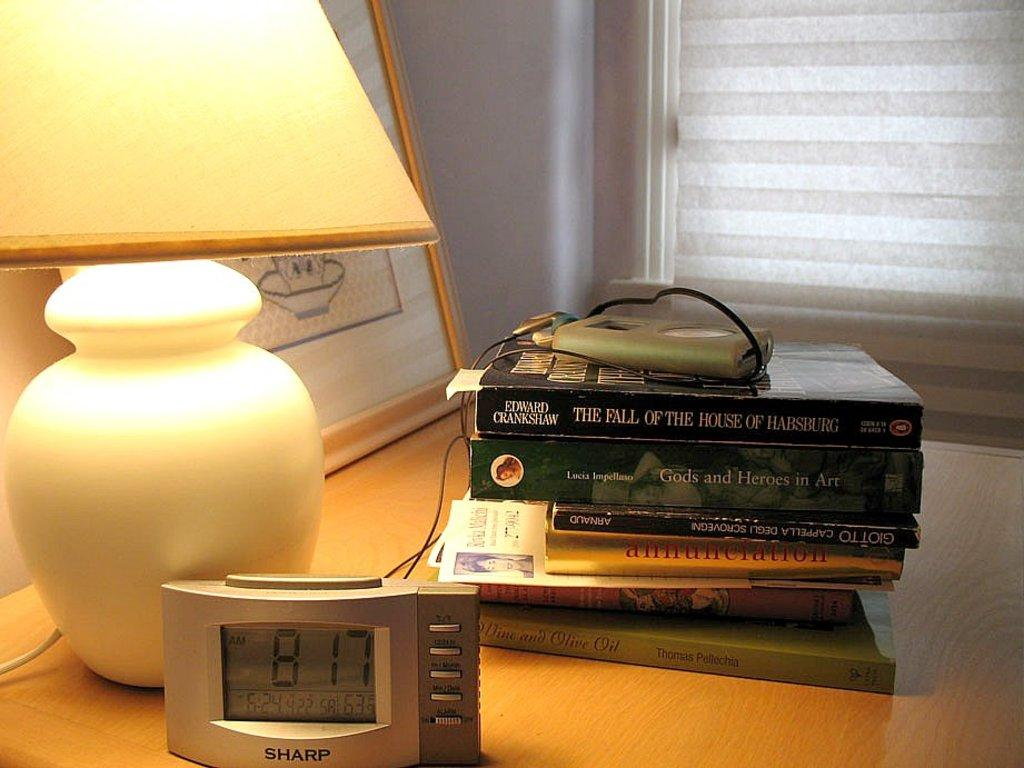<image>
Offer a succinct explanation of the picture presented. A night stand with a lamp on showing 8:17 on the sharp clock with a stack of books behind it. 